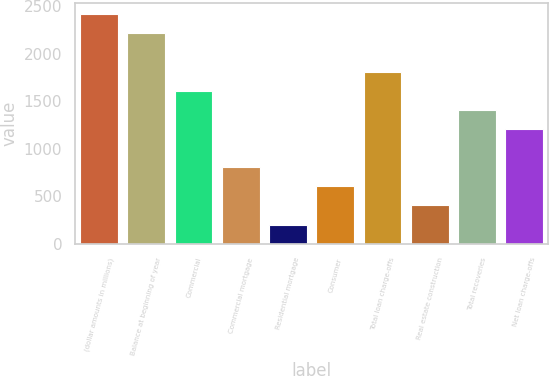Convert chart. <chart><loc_0><loc_0><loc_500><loc_500><bar_chart><fcel>(dollar amounts in millions)<fcel>Balance at beginning of year<fcel>Commercial<fcel>Commercial mortgage<fcel>Residential mortgage<fcel>Consumer<fcel>Total loan charge-offs<fcel>Real estate construction<fcel>Total recoveries<fcel>Net loan charge-offs<nl><fcel>2415.52<fcel>2214.24<fcel>1610.4<fcel>805.28<fcel>201.44<fcel>604<fcel>1811.68<fcel>402.72<fcel>1409.12<fcel>1207.84<nl></chart> 